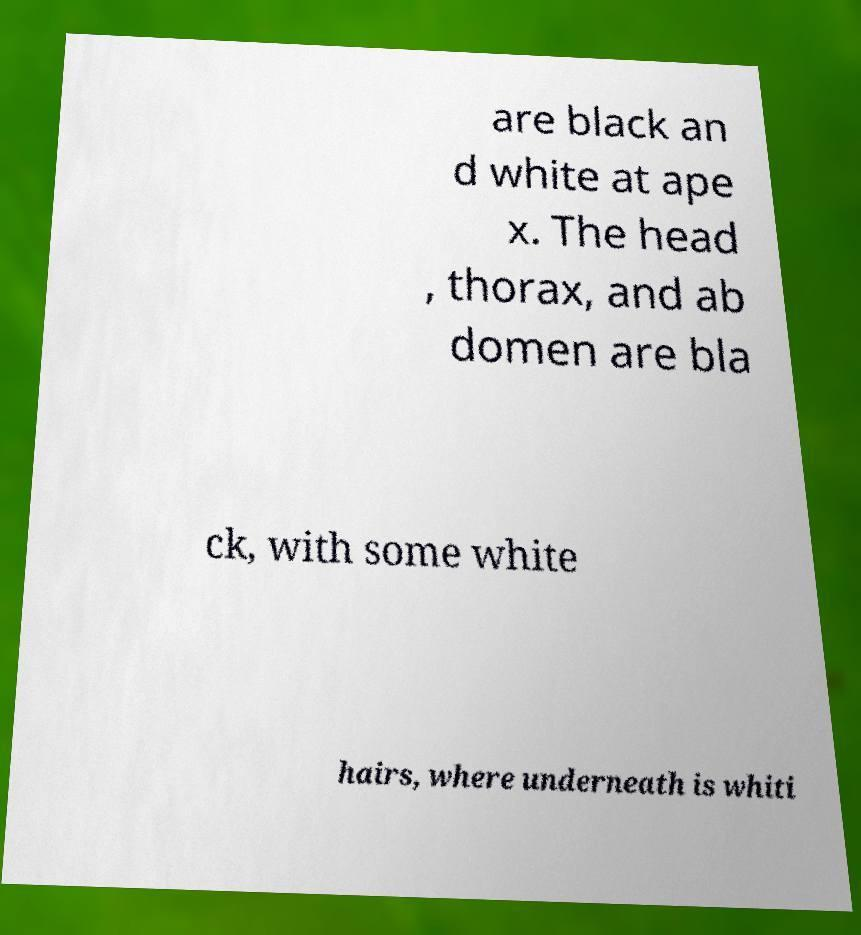Could you extract and type out the text from this image? are black an d white at ape x. The head , thorax, and ab domen are bla ck, with some white hairs, where underneath is whiti 